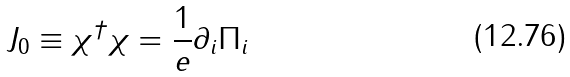Convert formula to latex. <formula><loc_0><loc_0><loc_500><loc_500>J _ { 0 } \equiv \chi ^ { \dagger } \chi = \frac { 1 } { e } \partial _ { i } \Pi _ { i }</formula> 